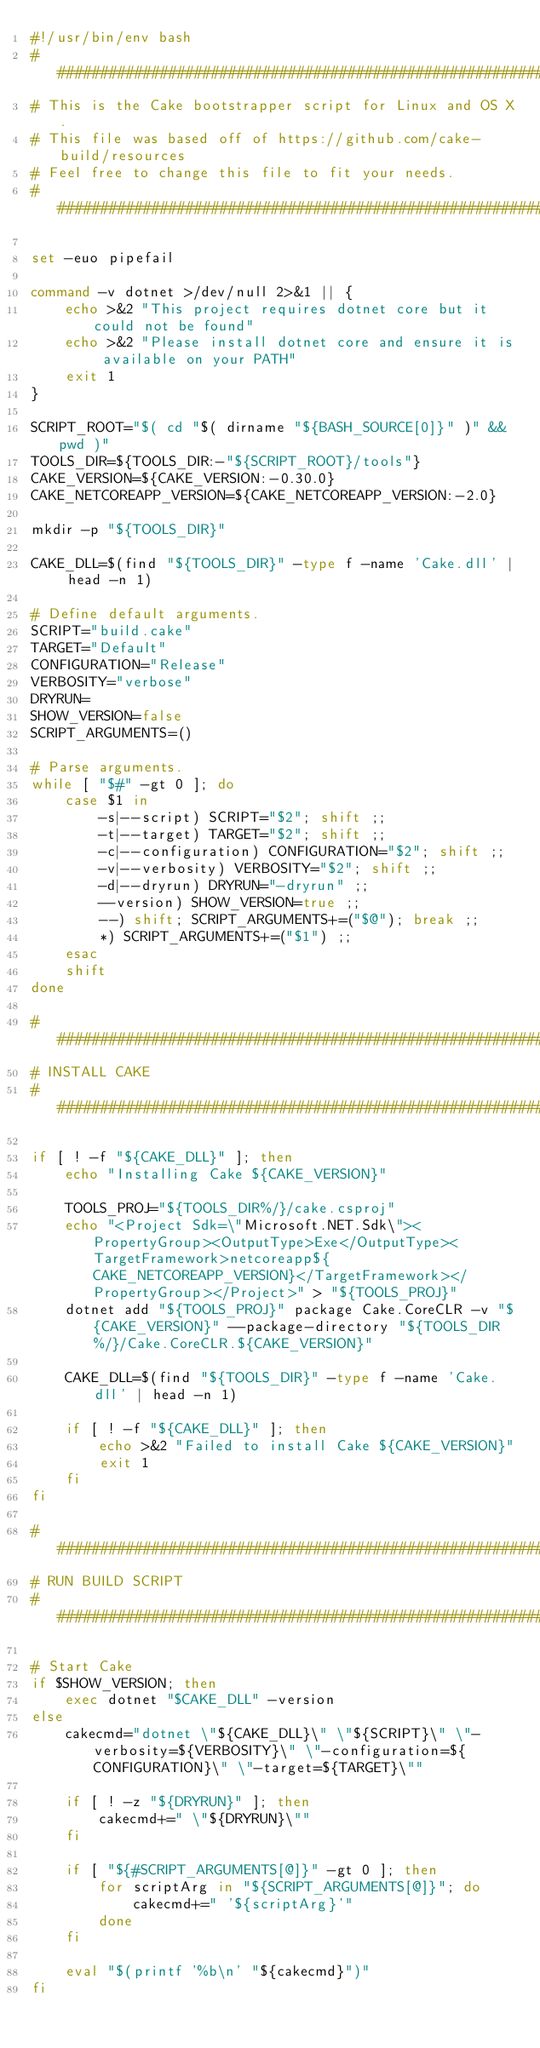<code> <loc_0><loc_0><loc_500><loc_500><_Bash_>#!/usr/bin/env bash
##########################################################################
# This is the Cake bootstrapper script for Linux and OS X.
# This file was based off of https://github.com/cake-build/resources
# Feel free to change this file to fit your needs.
##########################################################################

set -euo pipefail

command -v dotnet >/dev/null 2>&1 || { 
    echo >&2 "This project requires dotnet core but it could not be found"
    echo >&2 "Please install dotnet core and ensure it is available on your PATH"
    exit 1
}

SCRIPT_ROOT="$( cd "$( dirname "${BASH_SOURCE[0]}" )" && pwd )"
TOOLS_DIR=${TOOLS_DIR:-"${SCRIPT_ROOT}/tools"}
CAKE_VERSION=${CAKE_VERSION:-0.30.0}
CAKE_NETCOREAPP_VERSION=${CAKE_NETCOREAPP_VERSION:-2.0}

mkdir -p "${TOOLS_DIR}"

CAKE_DLL=$(find "${TOOLS_DIR}" -type f -name 'Cake.dll' | head -n 1)

# Define default arguments.
SCRIPT="build.cake"
TARGET="Default"
CONFIGURATION="Release"
VERBOSITY="verbose"
DRYRUN=
SHOW_VERSION=false
SCRIPT_ARGUMENTS=()

# Parse arguments.
while [ "$#" -gt 0 ]; do
    case $1 in
        -s|--script) SCRIPT="$2"; shift ;;
        -t|--target) TARGET="$2"; shift ;;
        -c|--configuration) CONFIGURATION="$2"; shift ;;
        -v|--verbosity) VERBOSITY="$2"; shift ;;
        -d|--dryrun) DRYRUN="-dryrun" ;;
        --version) SHOW_VERSION=true ;;
        --) shift; SCRIPT_ARGUMENTS+=("$@"); break ;;
        *) SCRIPT_ARGUMENTS+=("$1") ;;
    esac
    shift
done

###########################################################################
# INSTALL CAKE
###########################################################################

if [ ! -f "${CAKE_DLL}" ]; then
    echo "Installing Cake ${CAKE_VERSION}"

    TOOLS_PROJ="${TOOLS_DIR%/}/cake.csproj"
    echo "<Project Sdk=\"Microsoft.NET.Sdk\"><PropertyGroup><OutputType>Exe</OutputType><TargetFramework>netcoreapp${CAKE_NETCOREAPP_VERSION}</TargetFramework></PropertyGroup></Project>" > "${TOOLS_PROJ}"
    dotnet add "${TOOLS_PROJ}" package Cake.CoreCLR -v "${CAKE_VERSION}" --package-directory "${TOOLS_DIR%/}/Cake.CoreCLR.${CAKE_VERSION}"

    CAKE_DLL=$(find "${TOOLS_DIR}" -type f -name 'Cake.dll' | head -n 1)

    if [ ! -f "${CAKE_DLL}" ]; then
        echo >&2 "Failed to install Cake ${CAKE_VERSION}"
        exit 1
    fi
fi

###########################################################################
# RUN BUILD SCRIPT
###########################################################################
 
# Start Cake
if $SHOW_VERSION; then
    exec dotnet "$CAKE_DLL" -version
else
    cakecmd="dotnet \"${CAKE_DLL}\" \"${SCRIPT}\" \"-verbosity=${VERBOSITY}\" \"-configuration=${CONFIGURATION}\" \"-target=${TARGET}\""

    if [ ! -z "${DRYRUN}" ]; then
        cakecmd+=" \"${DRYRUN}\""
    fi

    if [ "${#SCRIPT_ARGUMENTS[@]}" -gt 0 ]; then
        for scriptArg in "${SCRIPT_ARGUMENTS[@]}"; do
            cakecmd+=" '${scriptArg}'"
        done
    fi

    eval "$(printf '%b\n' "${cakecmd}")"
fi
</code> 